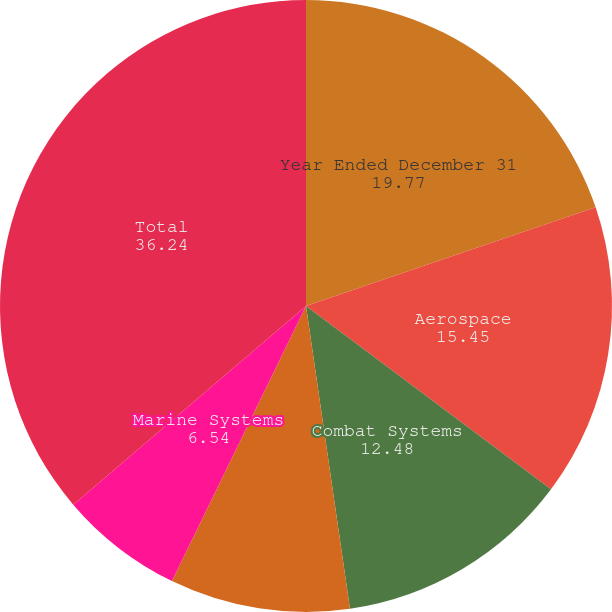Convert chart. <chart><loc_0><loc_0><loc_500><loc_500><pie_chart><fcel>Year Ended December 31<fcel>Aerospace<fcel>Combat Systems<fcel>Information Systems and<fcel>Marine Systems<fcel>Total<nl><fcel>19.77%<fcel>15.45%<fcel>12.48%<fcel>9.51%<fcel>6.54%<fcel>36.24%<nl></chart> 